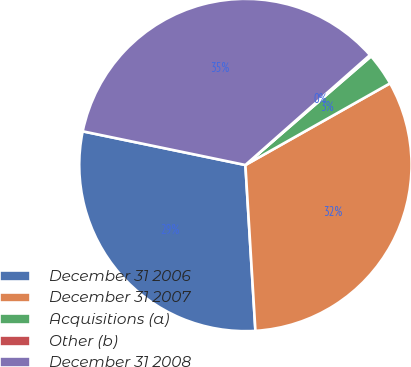<chart> <loc_0><loc_0><loc_500><loc_500><pie_chart><fcel>December 31 2006<fcel>December 31 2007<fcel>Acquisitions (a)<fcel>Other (b)<fcel>December 31 2008<nl><fcel>29.21%<fcel>32.22%<fcel>3.17%<fcel>0.16%<fcel>35.24%<nl></chart> 